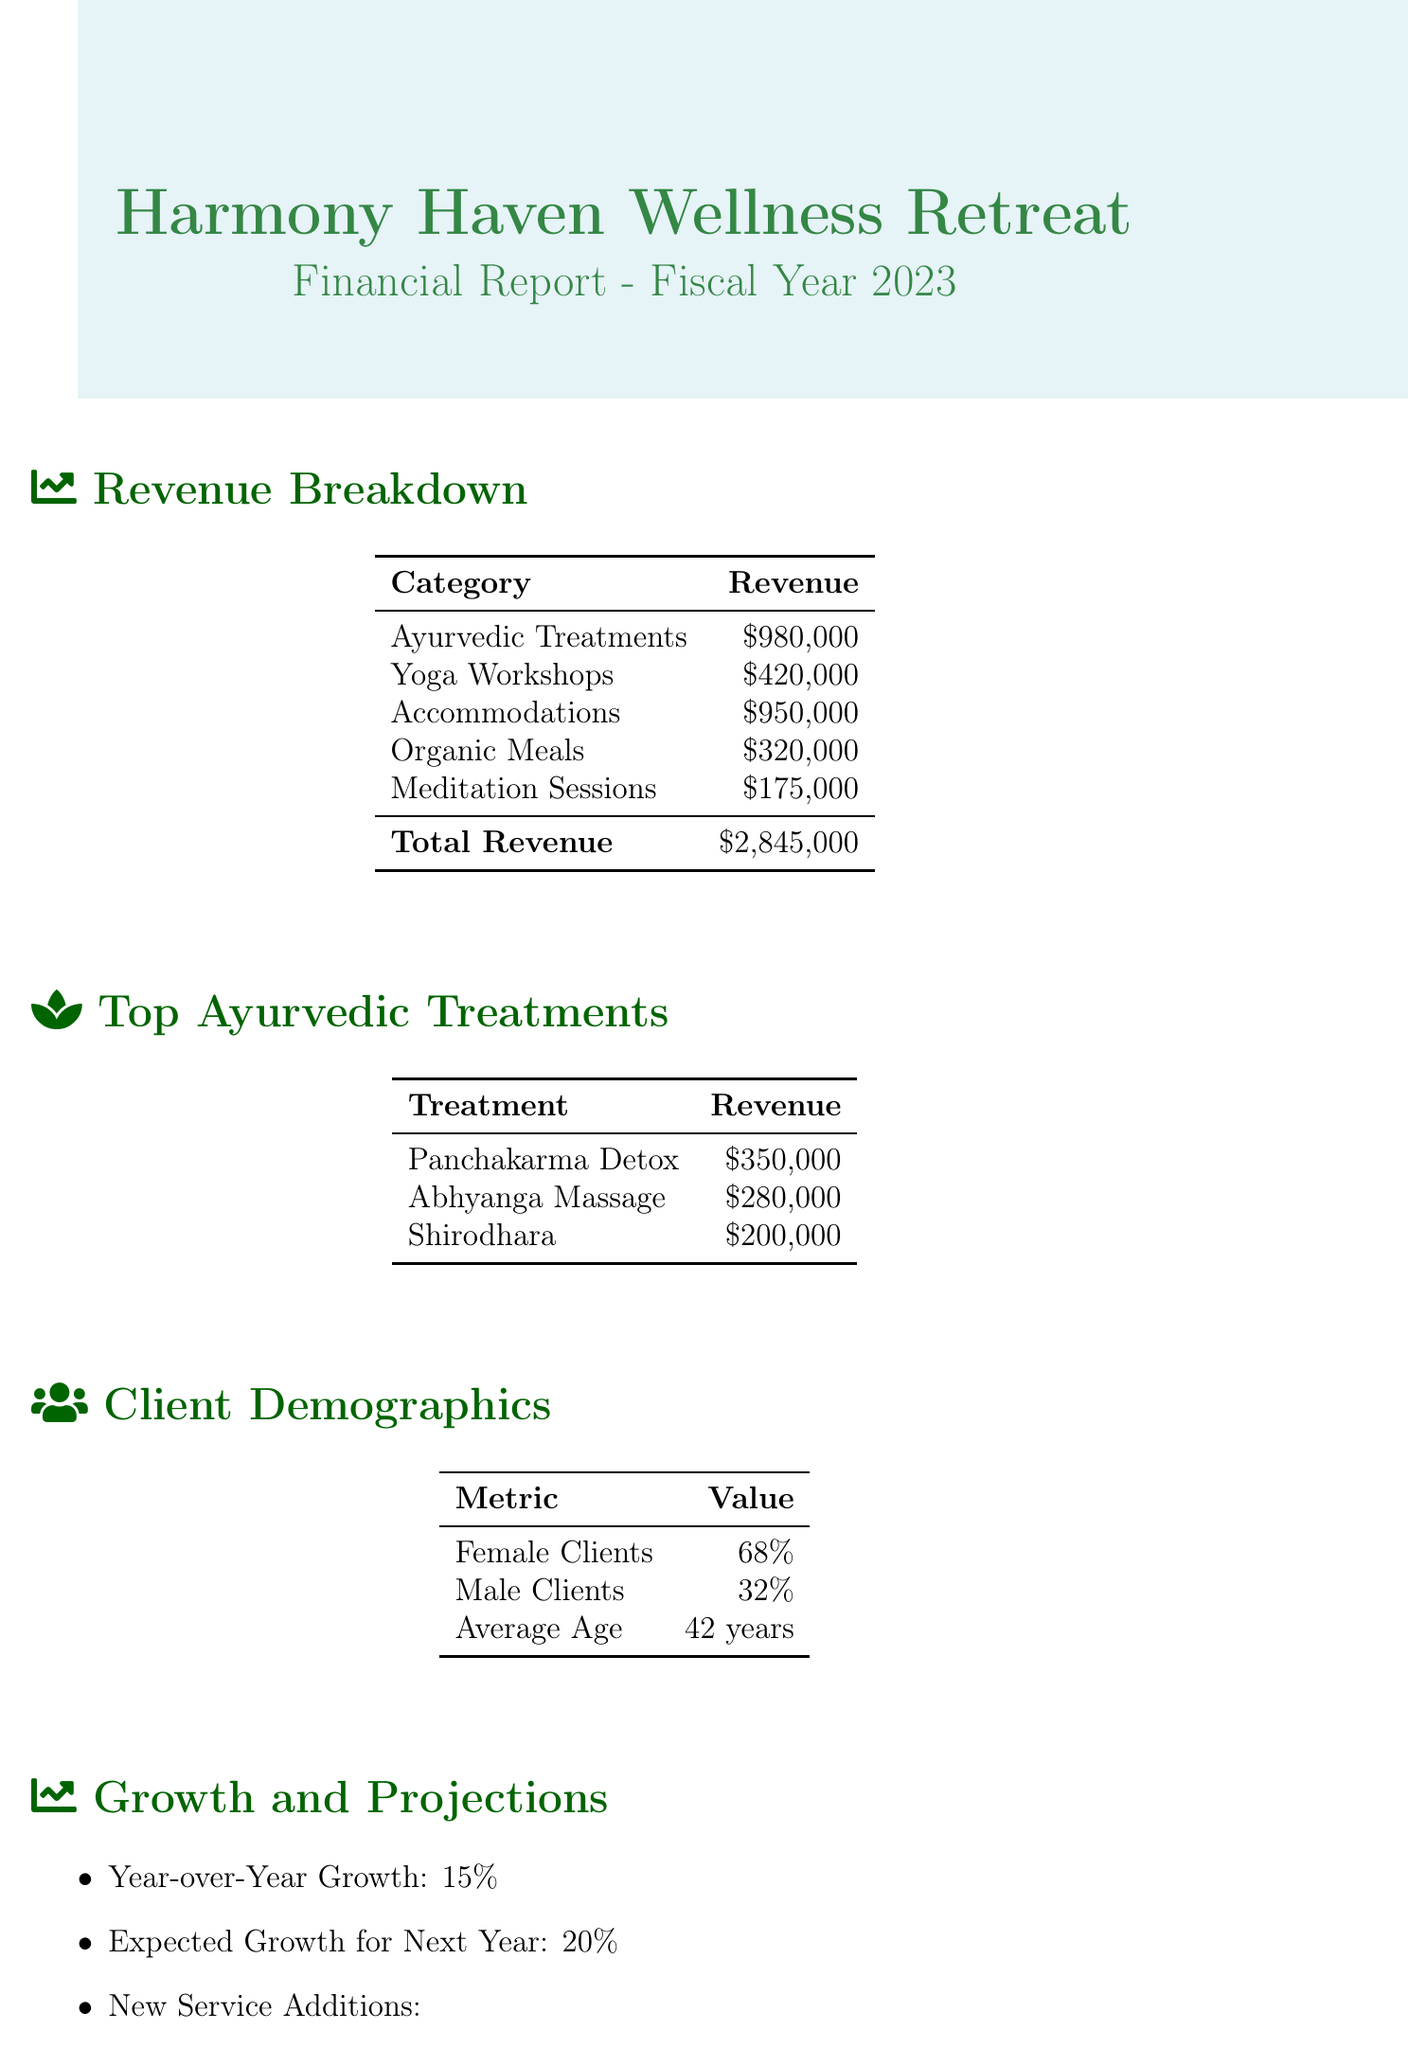what is the total revenue? The total revenue is the sum of all revenue sources listed in the document, which equals 980,000 + 420,000 + 950,000 + 320,000 + 175,000.
Answer: $2,845,000 how much revenue did Ayurvedic treatments generate? This figure is specifically stated in the revenue breakdown section of the document.
Answer: $980,000 what is the revenue from Panchakarma Detox? The revenue from this treatment is mentioned in the top Ayurvedic treatments section.
Answer: $350,000 what percentage of clients are female? This percentage is provided in the client demographics section of the document.
Answer: 68% what is the expected growth for the next year? This figure is stated explicitly in the future projections section of the document.
Answer: 20% which treatment generated $200,000? The revenue for this treatment is indicated in the top Ayurvedic treatments section.
Answer: Shirodhara how many people are typically male clients? The percentage of male clients is noted in the client demographics section.
Answer: 32% what new service additions are planned? The new services listed in the future projections section of the document indicate what will be added.
Answer: Ayurvedic Beauty Treatments, Corporate Wellness Retreats what was the year-over-year growth? The year-over-year growth is explicitly mentioned in the growth and projections section.
Answer: 15% 